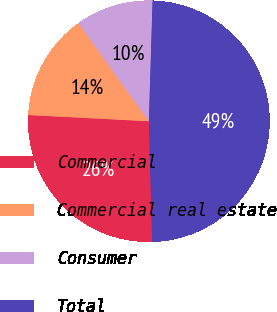Convert chart. <chart><loc_0><loc_0><loc_500><loc_500><pie_chart><fcel>Commercial<fcel>Commercial real estate<fcel>Consumer<fcel>Total<nl><fcel>26.25%<fcel>14.27%<fcel>10.4%<fcel>49.07%<nl></chart> 